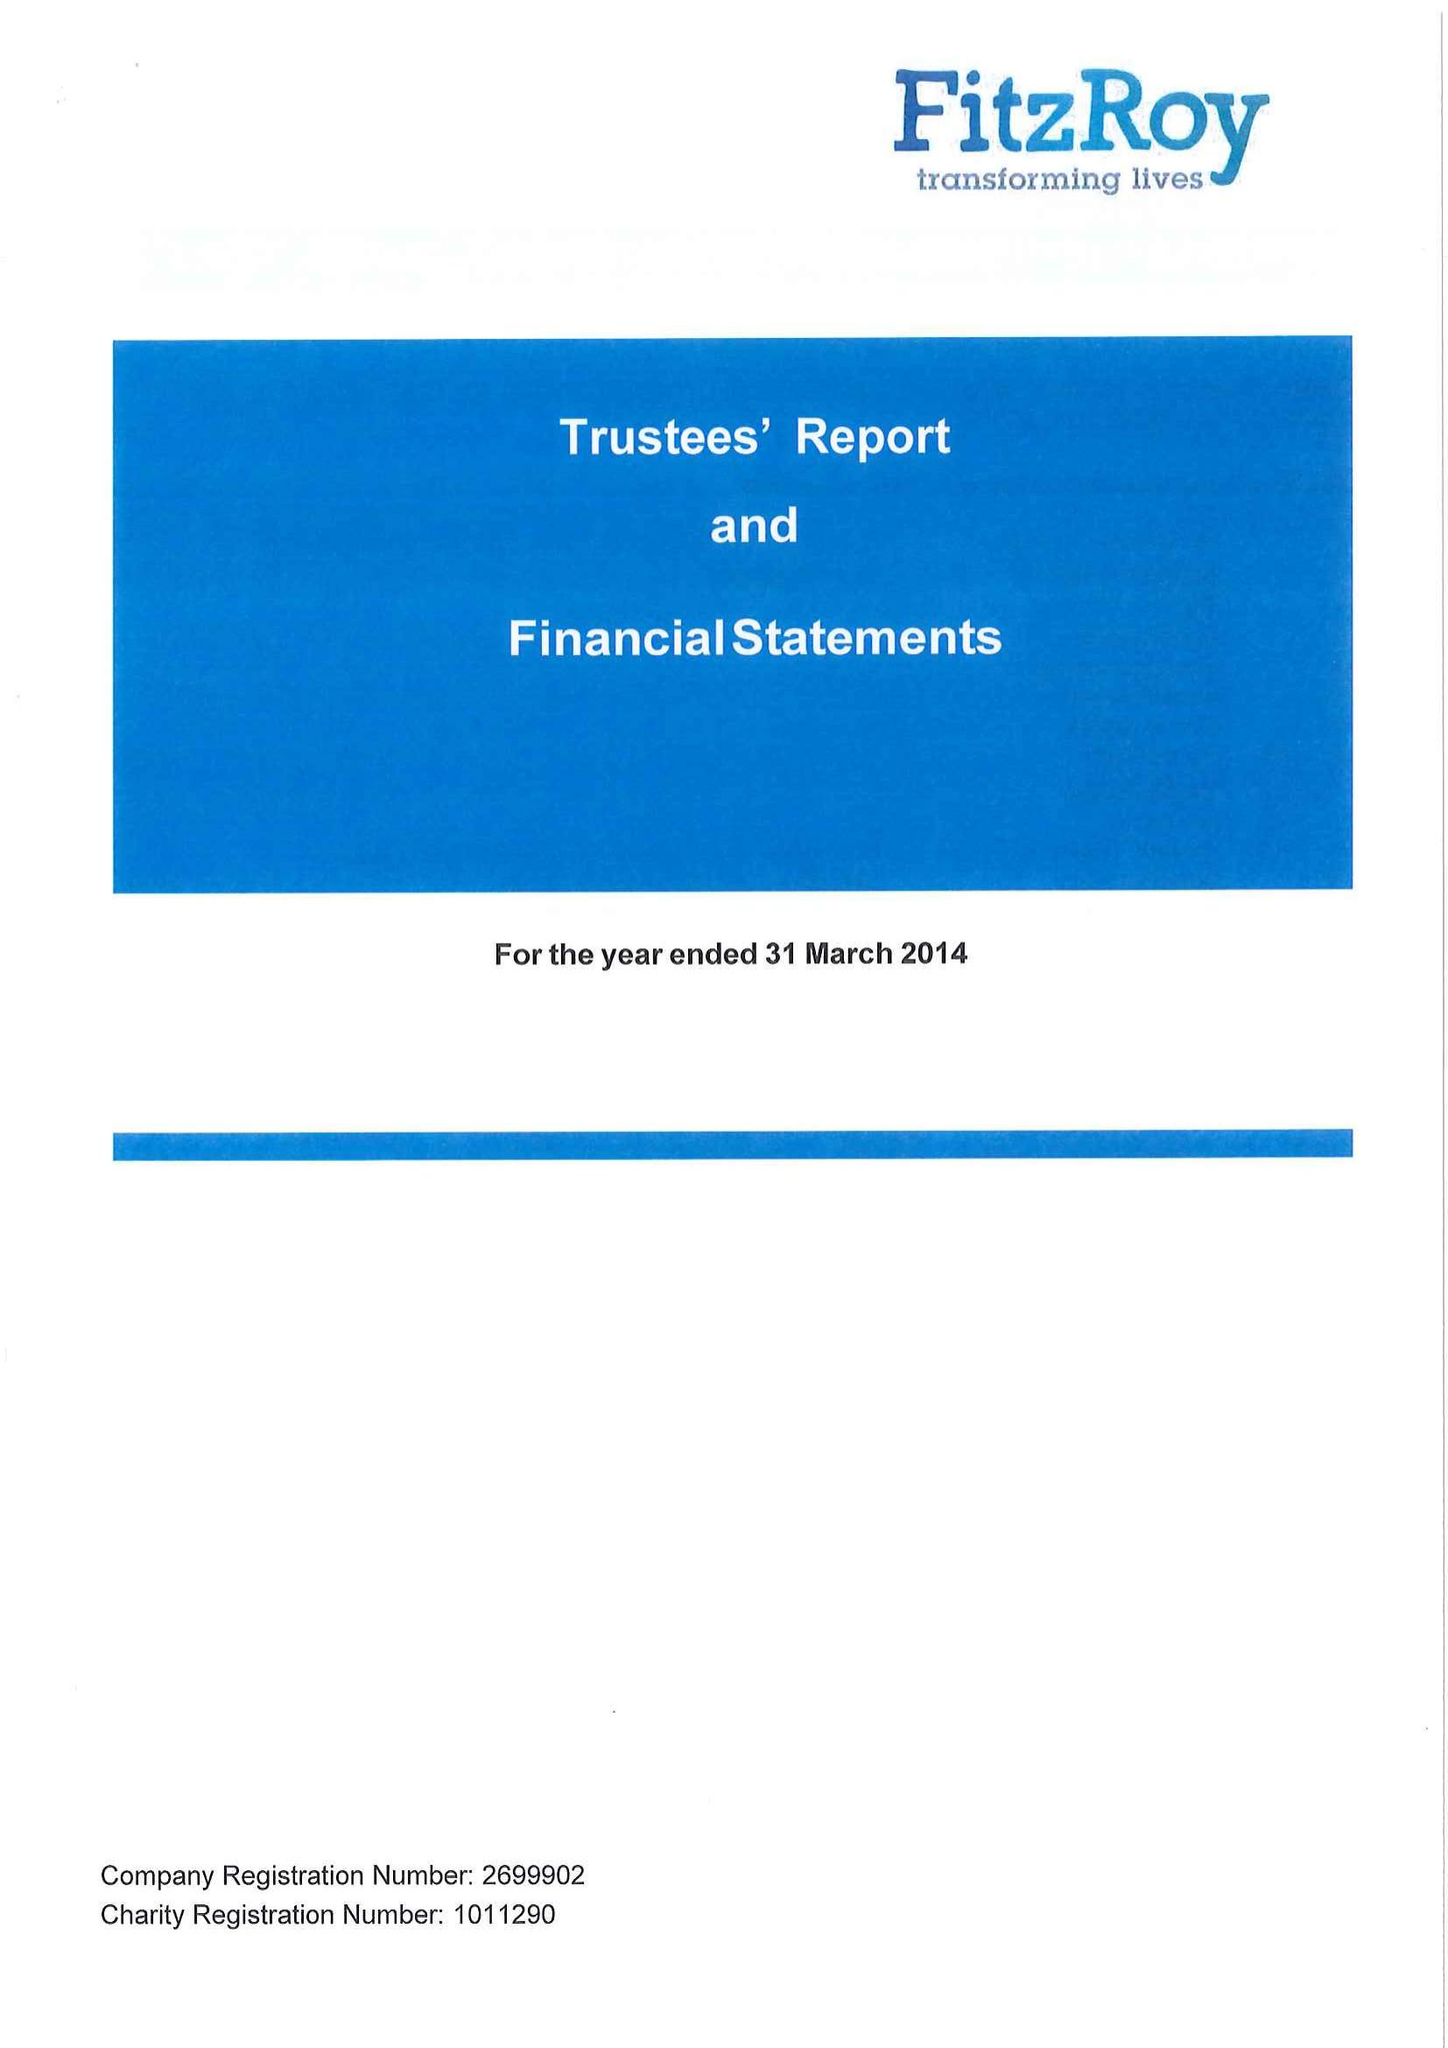What is the value for the charity_number?
Answer the question using a single word or phrase. 1011290 